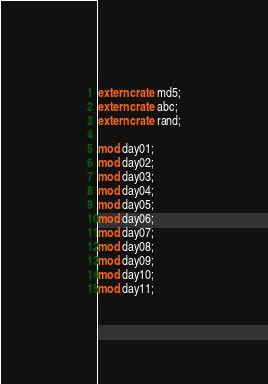Convert code to text. <code><loc_0><loc_0><loc_500><loc_500><_Rust_>extern crate md5;
extern crate abc;
extern crate rand;

mod day01;
mod day02;
mod day03;
mod day04;
mod day05;
mod day06;
mod day07;
mod day08;
mod day09;
mod day10;
mod day11;
</code> 